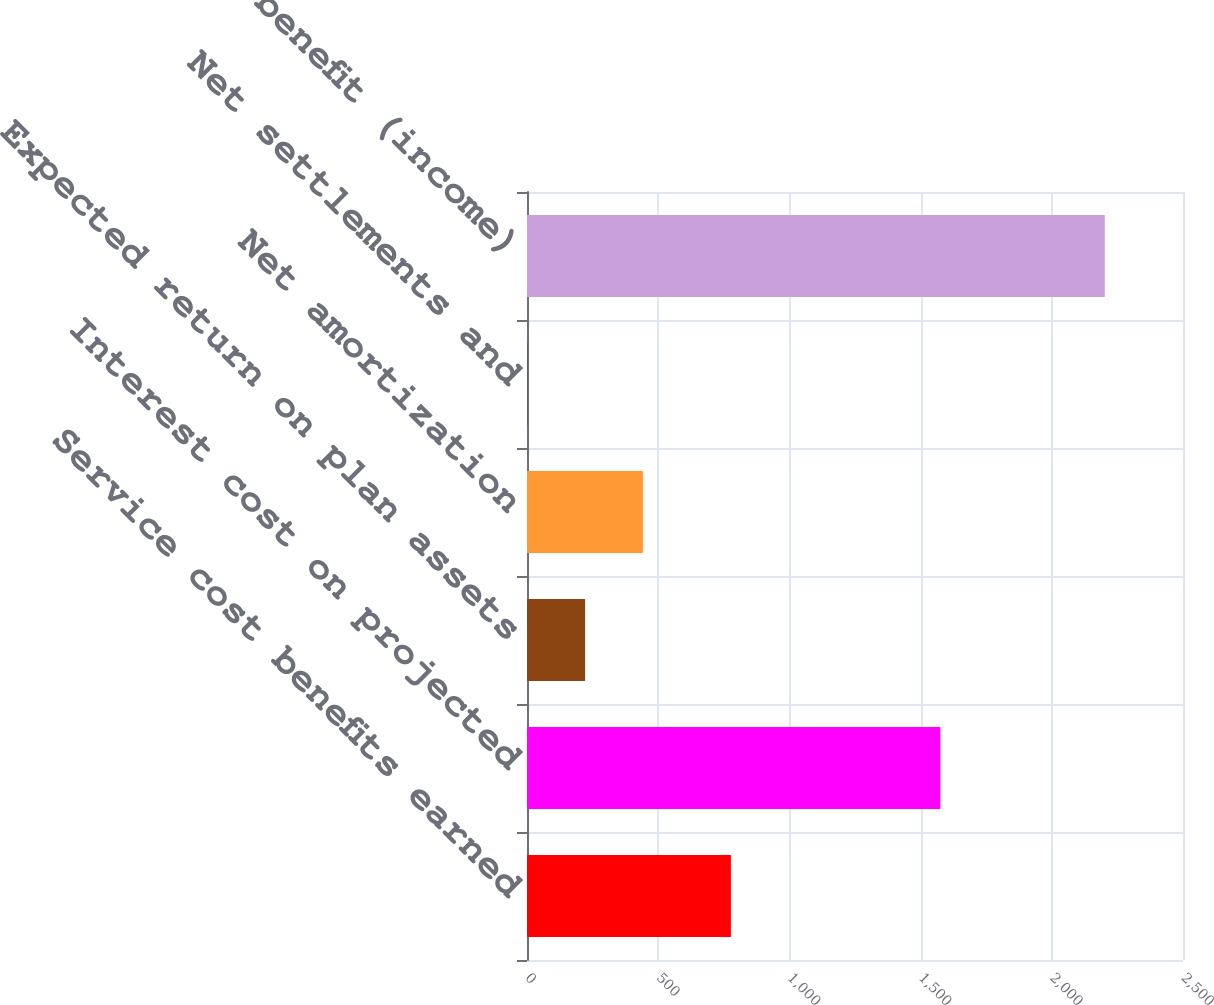Convert chart to OTSL. <chart><loc_0><loc_0><loc_500><loc_500><bar_chart><fcel>Service cost benefits earned<fcel>Interest cost on projected<fcel>Expected return on plan assets<fcel>Net amortization<fcel>Net settlements and<fcel>Net periodic benefit (income)<nl><fcel>777<fcel>1575<fcel>221.48<fcel>441.54<fcel>1.42<fcel>2202<nl></chart> 